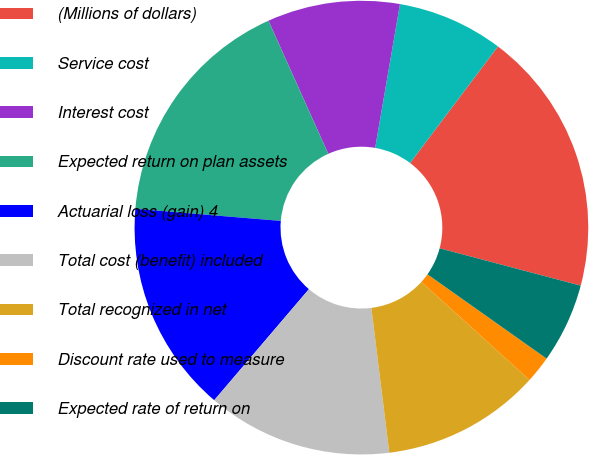<chart> <loc_0><loc_0><loc_500><loc_500><pie_chart><fcel>(Millions of dollars)<fcel>Service cost<fcel>Interest cost<fcel>Expected return on plan assets<fcel>Actuarial loss (gain) 4<fcel>Total cost (benefit) included<fcel>Total recognized in net<fcel>Discount rate used to measure<fcel>Expected rate of return on<nl><fcel>18.84%<fcel>7.56%<fcel>9.44%<fcel>16.96%<fcel>15.08%<fcel>13.2%<fcel>11.32%<fcel>1.92%<fcel>5.68%<nl></chart> 